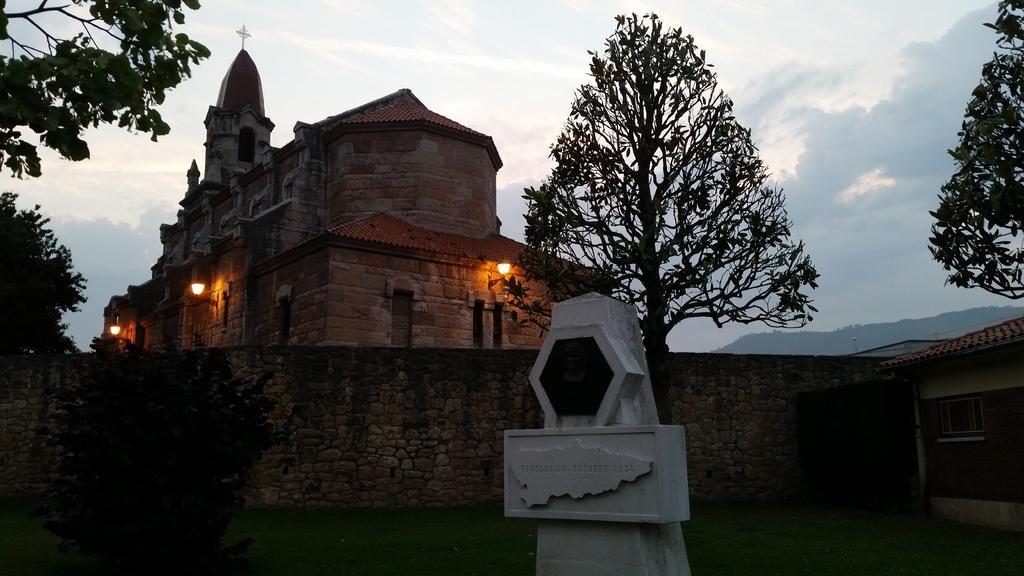Can you describe this image briefly? In the foreground of this image, there is a stone. Behind it, there are trees, building and a wall. On the right, there is a wall, window and the roof. At the top, there is the sky. 